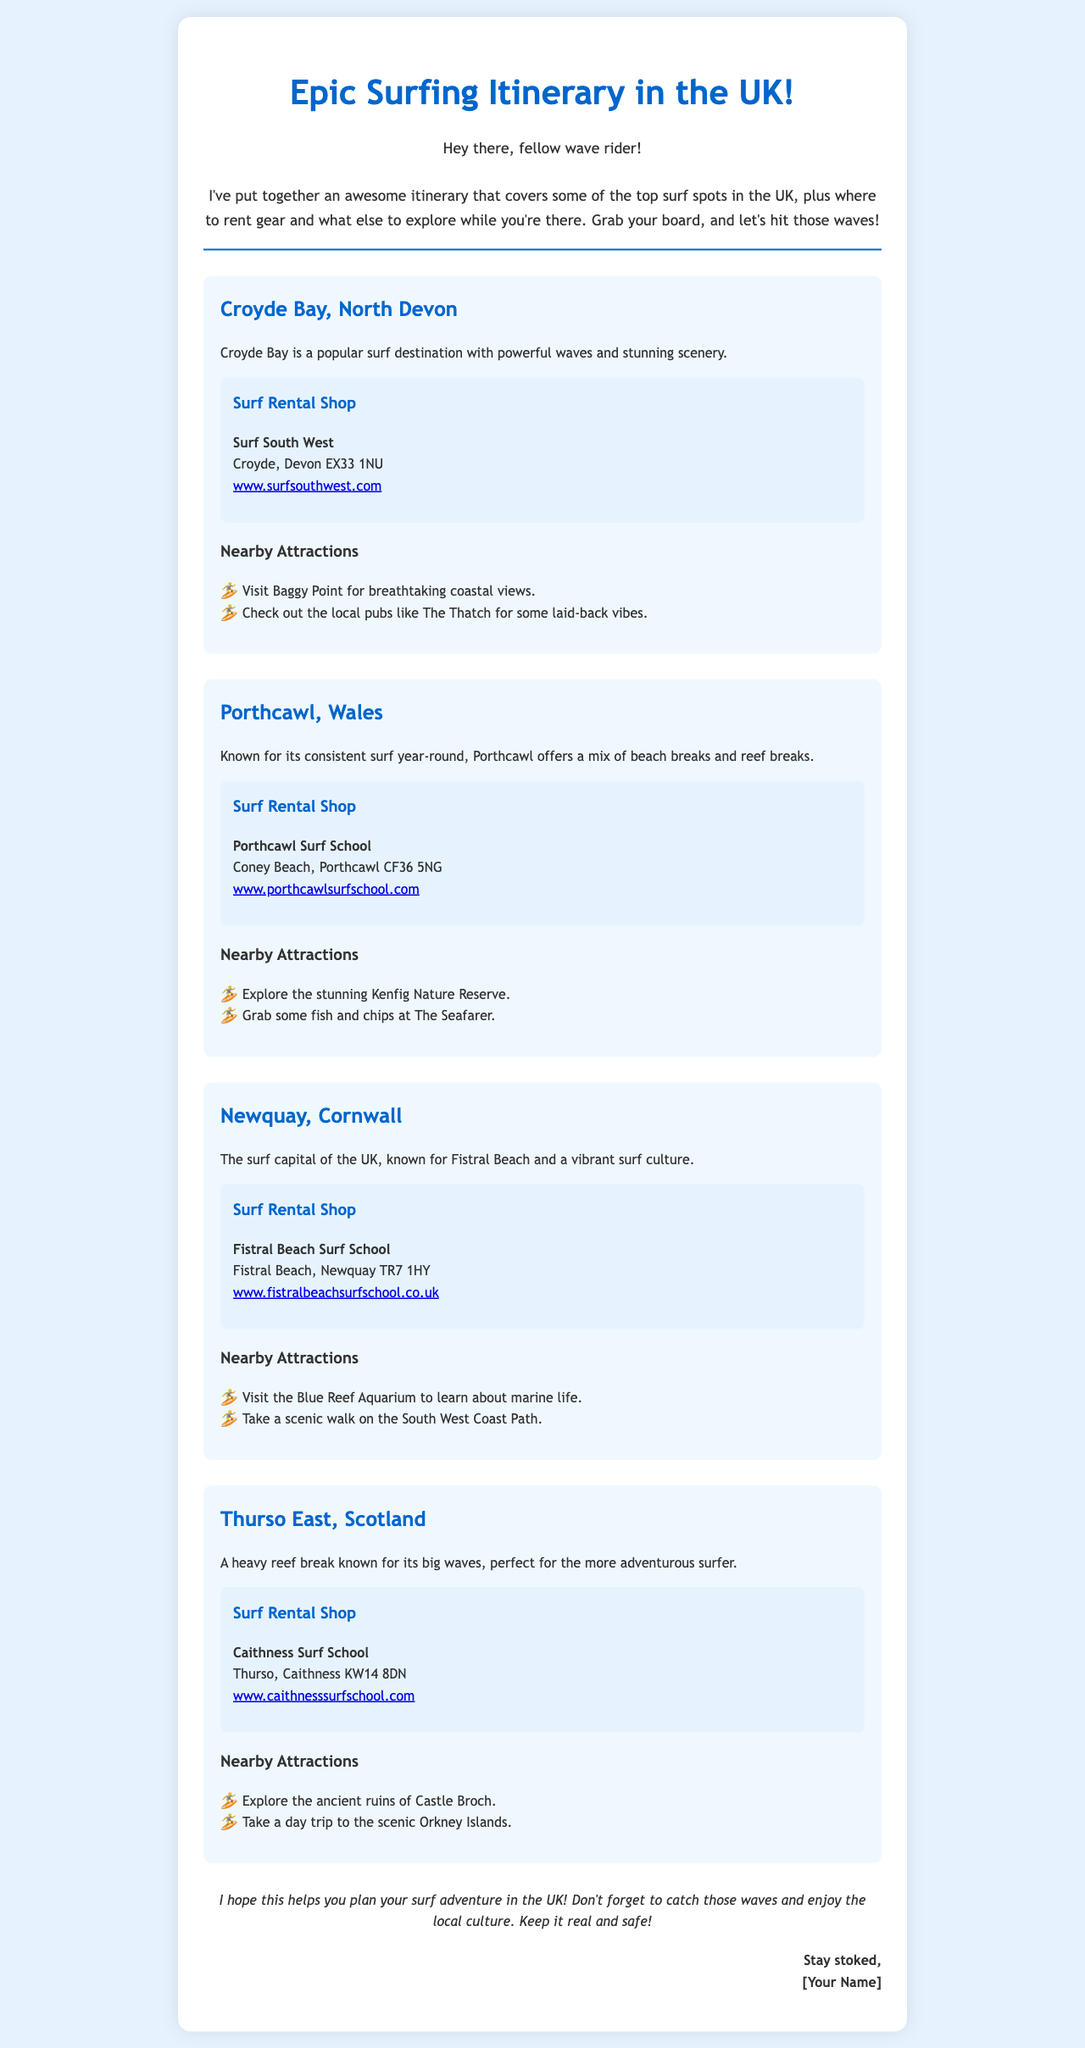What is the title of the itinerary? The title is displayed prominently at the top of the document.
Answer: Epic Surfing Itinerary in the UK! What surf spot is located in North Devon? This information is explicitly mentioned in the location section of the document.
Answer: Croyde Bay Which surf rental shop is in Porthcawl? This name is listed under the rental shop section for Porthcawl.
Answer: Porthcawl Surf School What nearby attraction can you visit in Newquay? The nearby attractions for Newquay are listed below the surf spot description.
Answer: Blue Reef Aquarium How many surf spots are mentioned in the itinerary? Counting the locations listed in the document will provide this number.
Answer: Four Which surf location is known for its big waves? This detail is highlighted in the description of the surf spot.
Answer: Thurso East What is the website for Surf South West? The website link is provided in the rental shop section under Croyde Bay.
Answer: www.surfsouthwest.com What is a recommended food spot in Porthcawl? This information is found under the nearby attractions section for Porthcawl.
Answer: The Seafarer What is the main theme of the itinerary? The introduction of the document describes the purpose and focus.
Answer: Surfing spots in the UK 